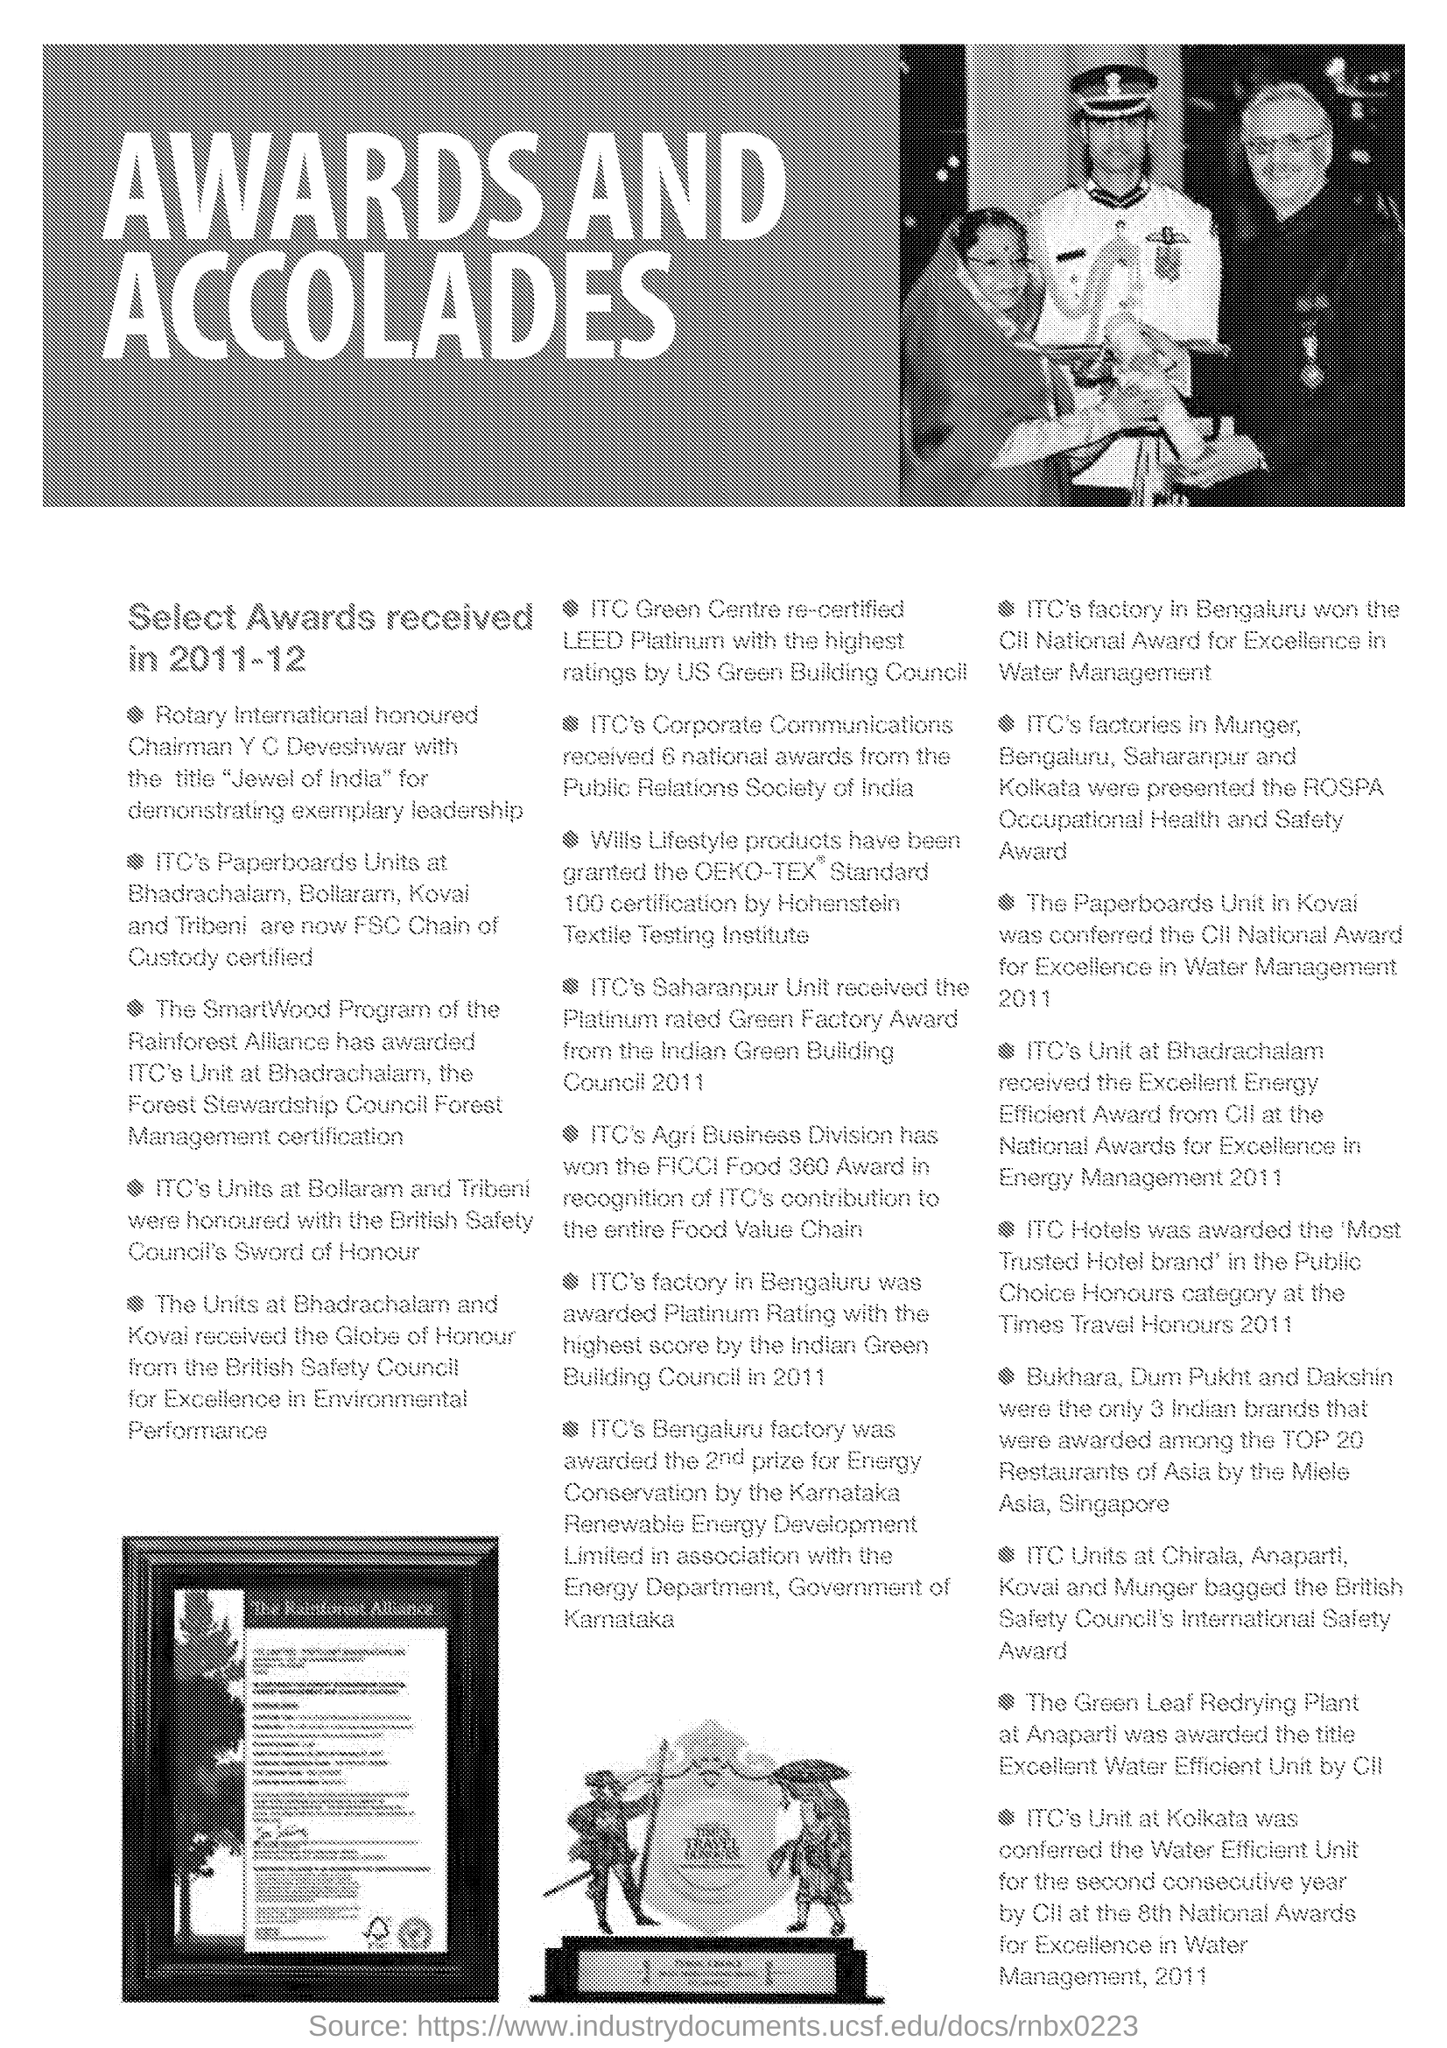Outline some significant characteristics in this image. The honorary title "Jewel of India" was bestowed upon Chairman Y.C. Deveshwar for his exceptional leadership and outstanding contributions to the field of business and industry. The Letter Head contains the written text 'Awards and accolades..' 